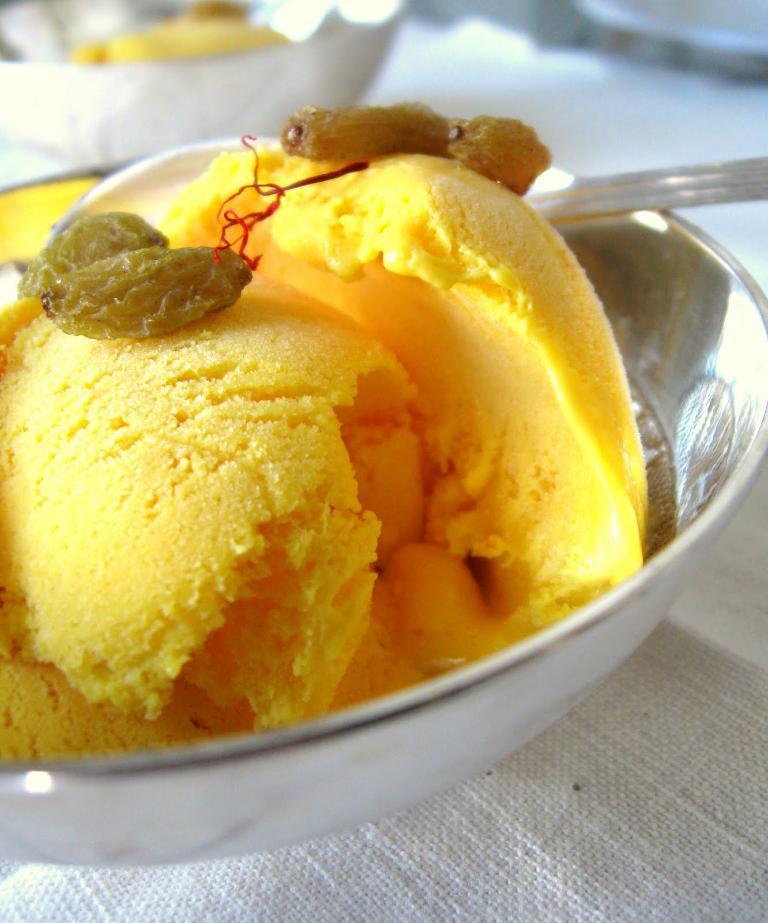Can you describe this image briefly? In this picture ,there is bowl and some ice cream in it. 